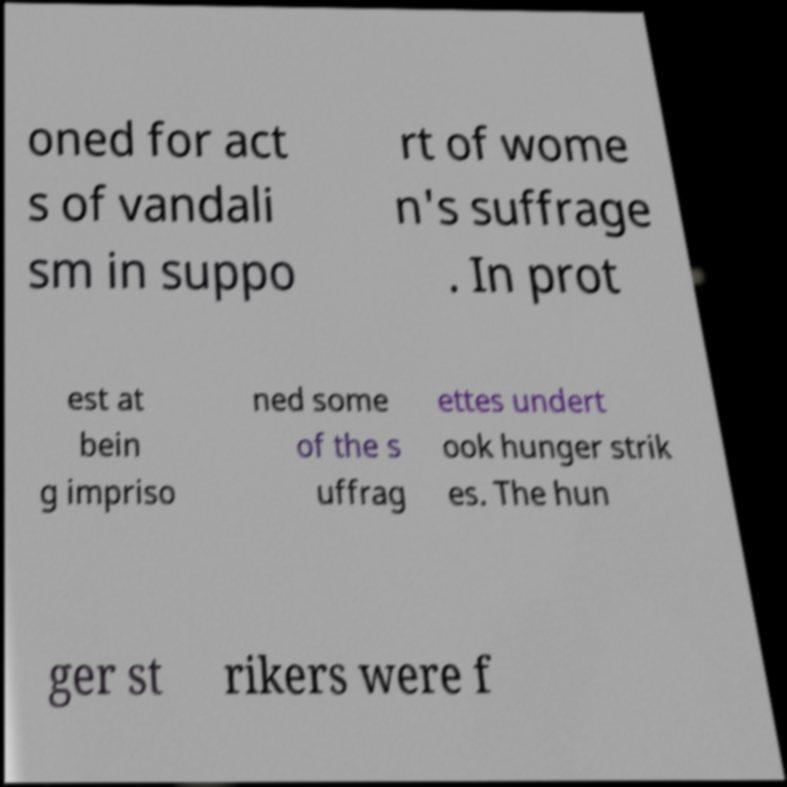Could you extract and type out the text from this image? oned for act s of vandali sm in suppo rt of wome n's suffrage . In prot est at bein g impriso ned some of the s uffrag ettes undert ook hunger strik es. The hun ger st rikers were f 